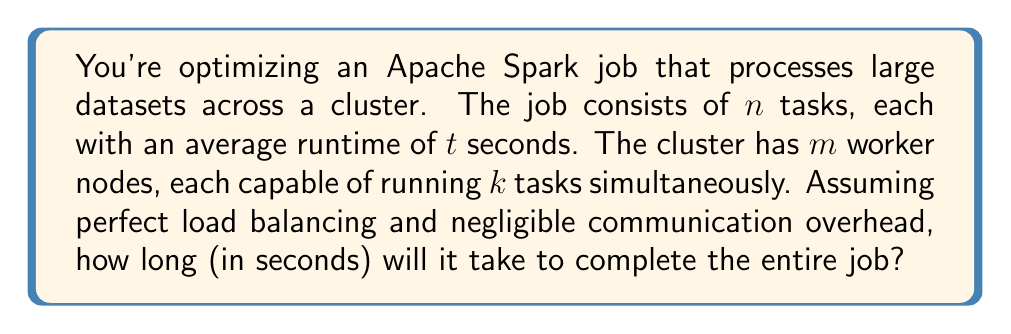Can you answer this question? Let's approach this step-by-step:

1) First, we need to calculate the total number of task slots available in the cluster:
   Total slots = $m \times k$

2) Now, we need to determine how many batches of tasks we'll need to run:
   Number of batches = $\left\lceil\frac{n}{m \times k}\right\rceil$
   We use the ceiling function because if there's a partial batch, we need to round up to the next full batch.

3) Each batch will take $t$ seconds to complete (since all tasks in a batch run concurrently).

4) Therefore, the total time to complete all batches is:
   Total time = $t \times \left\lceil\frac{n}{m \times k}\right\rceil$

This formula gives us the total runtime of the Spark job in seconds, assuming ideal conditions.

Note: In a real Apache Spark environment, we would need to consider factors like data skew, network latency, and resource contention. However, for this simplified model, we're assuming perfect conditions as specified in the question.
Answer: $$t \times \left\lceil\frac{n}{m \times k}\right\rceil$$ 